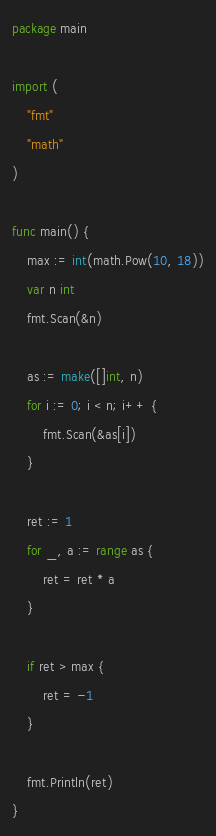<code> <loc_0><loc_0><loc_500><loc_500><_Go_>package main

import (
	"fmt"
	"math"
)

func main() {
	max := int(math.Pow(10, 18))
	var n int
	fmt.Scan(&n)

	as := make([]int, n)
	for i := 0; i < n; i++ {
		fmt.Scan(&as[i])
	}

	ret := 1
	for _, a := range as {
		ret = ret * a
	}

	if ret > max {
		ret = -1
	}

	fmt.Println(ret)
}</code> 